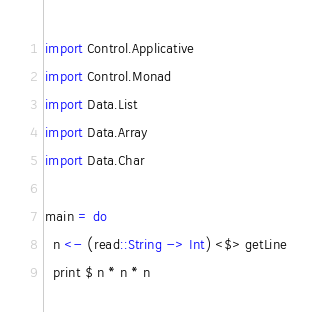<code> <loc_0><loc_0><loc_500><loc_500><_Haskell_>import Control.Applicative
import Control.Monad
import Data.List
import Data.Array
import Data.Char

main = do
  n <- (read::String -> Int) <$> getLine
  print $ n * n * n</code> 